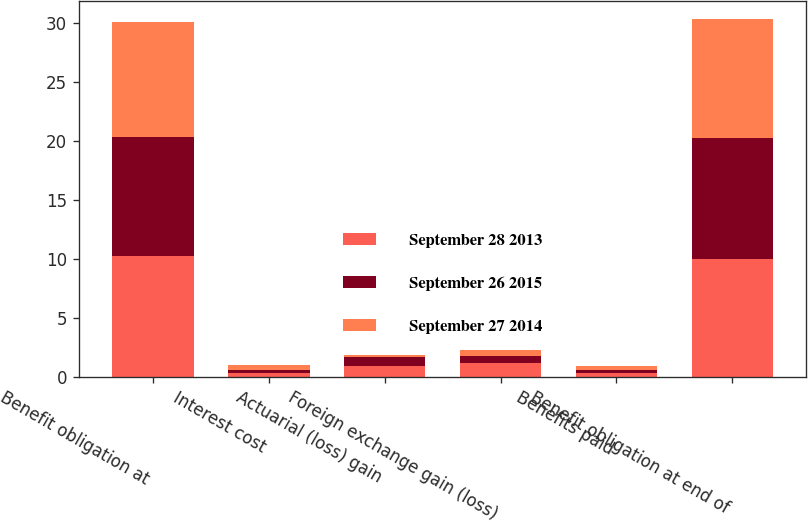<chart> <loc_0><loc_0><loc_500><loc_500><stacked_bar_chart><ecel><fcel>Benefit obligation at<fcel>Interest cost<fcel>Actuarial (loss) gain<fcel>Foreign exchange gain (loss)<fcel>Benefits paid<fcel>Benefit obligation at end of<nl><fcel>September 28 2013<fcel>10.3<fcel>0.3<fcel>0.9<fcel>1.2<fcel>0.3<fcel>10<nl><fcel>September 26 2015<fcel>10.1<fcel>0.3<fcel>0.8<fcel>0.6<fcel>0.3<fcel>10.3<nl><fcel>September 27 2014<fcel>9.7<fcel>0.4<fcel>0.2<fcel>0.5<fcel>0.3<fcel>10.1<nl></chart> 